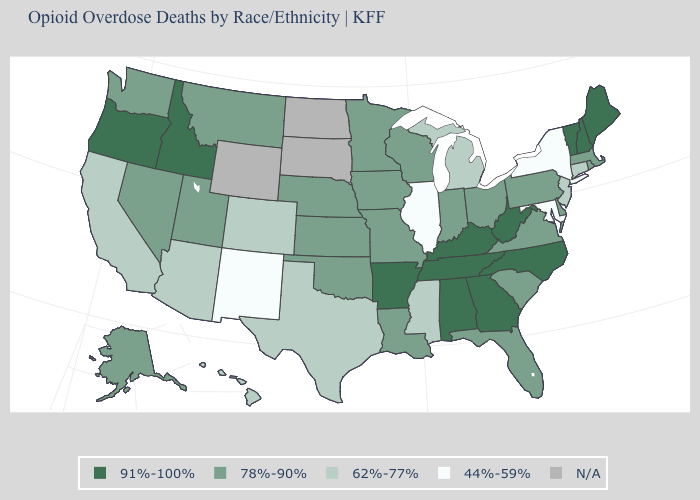Does the map have missing data?
Write a very short answer. Yes. Name the states that have a value in the range 91%-100%?
Give a very brief answer. Alabama, Arkansas, Georgia, Idaho, Kentucky, Maine, New Hampshire, North Carolina, Oregon, Tennessee, Vermont, West Virginia. What is the value of South Dakota?
Quick response, please. N/A. What is the value of Illinois?
Answer briefly. 44%-59%. What is the value of Rhode Island?
Answer briefly. 78%-90%. Name the states that have a value in the range 44%-59%?
Give a very brief answer. Illinois, Maryland, New Mexico, New York. What is the lowest value in states that border New Mexico?
Give a very brief answer. 62%-77%. What is the highest value in states that border Washington?
Give a very brief answer. 91%-100%. Among the states that border North Carolina , does Virginia have the lowest value?
Answer briefly. Yes. What is the lowest value in the USA?
Concise answer only. 44%-59%. Name the states that have a value in the range 78%-90%?
Keep it brief. Alaska, Delaware, Florida, Indiana, Iowa, Kansas, Louisiana, Massachusetts, Minnesota, Missouri, Montana, Nebraska, Nevada, Ohio, Oklahoma, Pennsylvania, Rhode Island, South Carolina, Utah, Virginia, Washington, Wisconsin. What is the value of Rhode Island?
Concise answer only. 78%-90%. Among the states that border Indiana , does Kentucky have the highest value?
Be succinct. Yes. Name the states that have a value in the range 44%-59%?
Quick response, please. Illinois, Maryland, New Mexico, New York. 